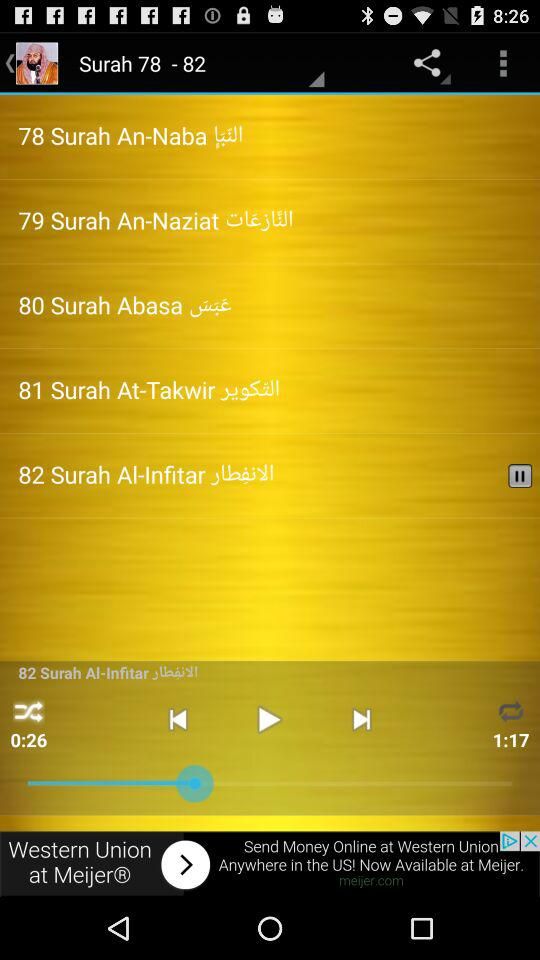What is the length of "Surah Al-Infitar"? The length of "Surah Al-Infitar" is 1 minute 17 seconds. 